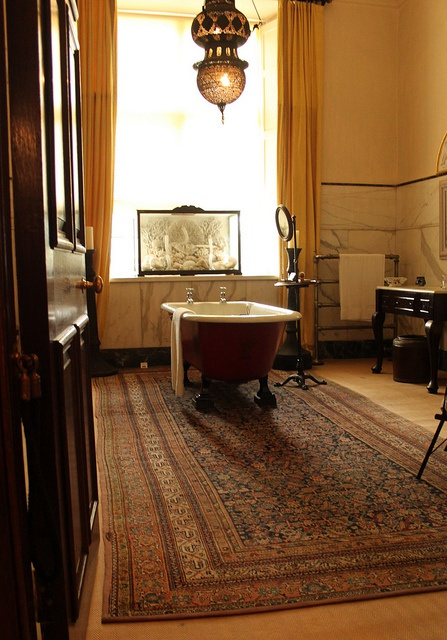Describe the objects in this image and their specific colors. I can see a bowl in black, olive, and maroon tones in this image. 